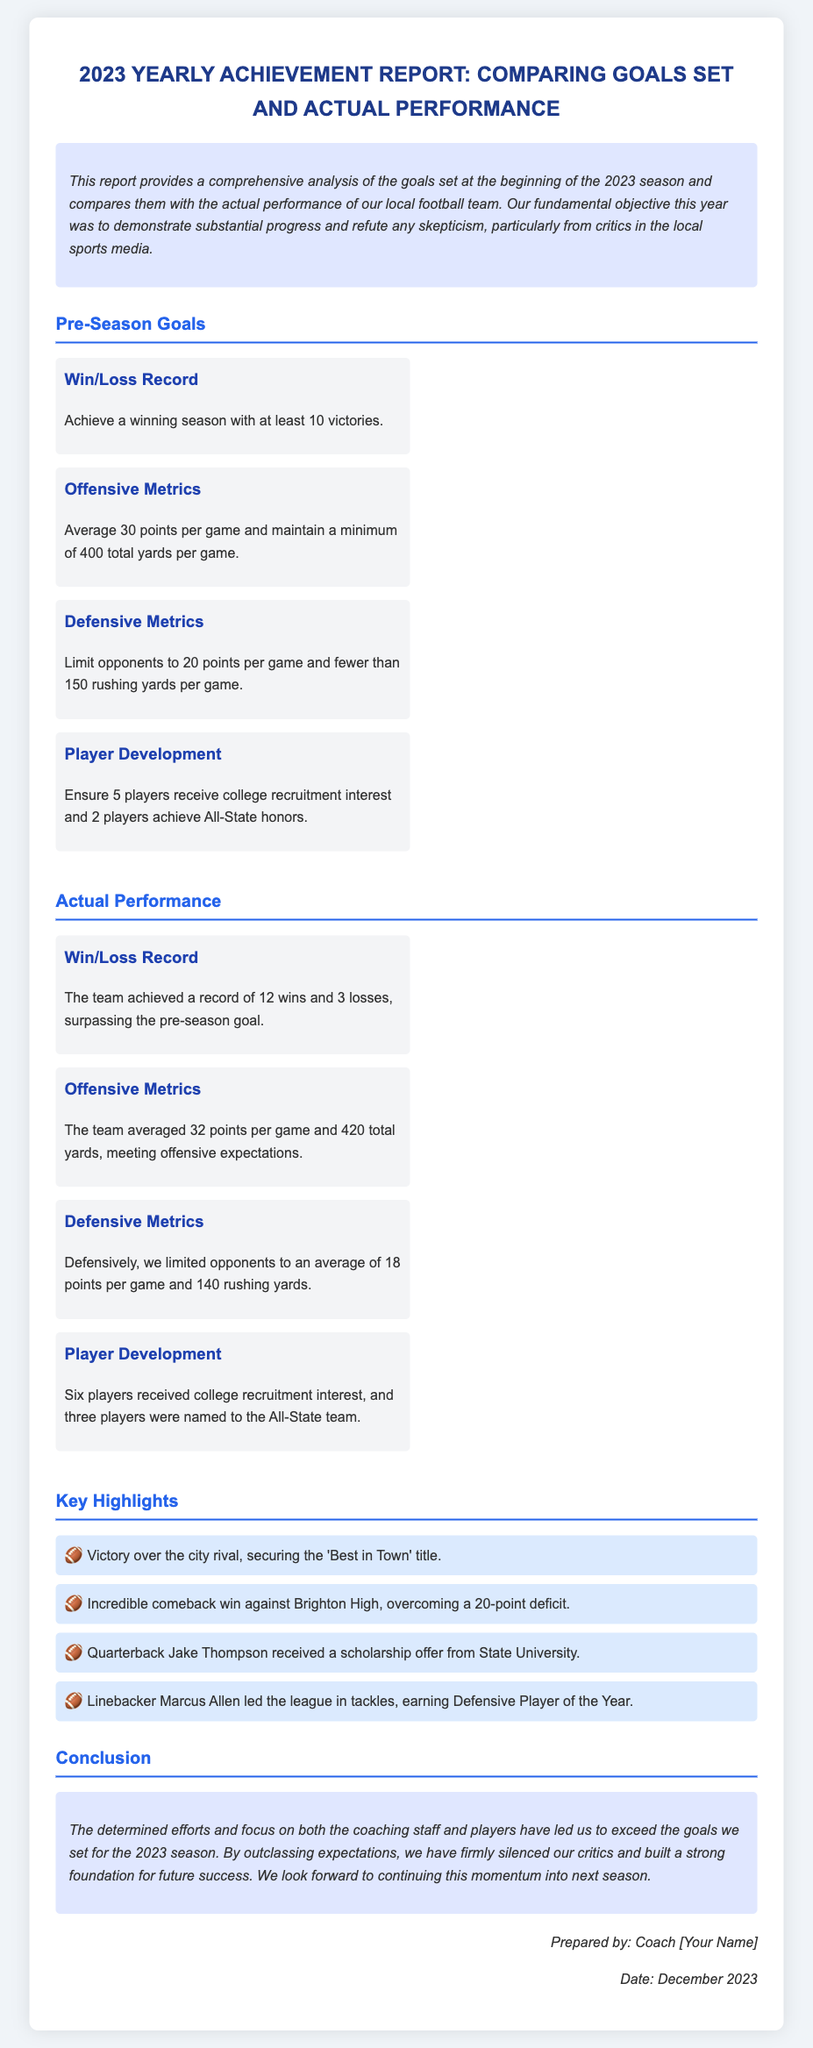What was the team's win/loss record for the season? The team achieved a record of 12 wins and 3 losses, which is stated in the 'Actual Performance' section.
Answer: 12 wins and 3 losses How many points did the team average per game? The team averaged 32 points per game according to the 'Actual Performance' section.
Answer: 32 points What was the minimum rushing yards allowed per game? The goal was to limit opponents to fewer than 150 rushing yards, as stated in the 'Defensive Metrics' section.
Answer: 150 rushing yards How many players received college recruitment interest? Six players received college recruitment interest, which is mentioned in the 'Actual Performance' section.
Answer: Six players Which team did the football team come back against to win? The incredible comeback win was against Brighton High, as highlighted in the 'Key Highlights' section.
Answer: Brighton High What is the primary objective stated for the 2023 season? The fundamental objective was to demonstrate substantial progress and refute skepticism, as mentioned in the 'Intro' paragraph.
Answer: Demonstrate substantial progress How many players achieved All-State honors? Three players were named to the All-State team, which is detailed in the 'Actual Performance' section.
Answer: Three players What title was secured by defeating the city rival? The team secured the 'Best in Town' title after defeating the city rival, as stated in the 'Key Highlights' section.
Answer: Best in Town What is the overall tone of the conclusion about the team's performance? The conclusion remarks on exceeding the goals and silencing critics, reflecting a positive and determined tone.
Answer: Positive and determined 